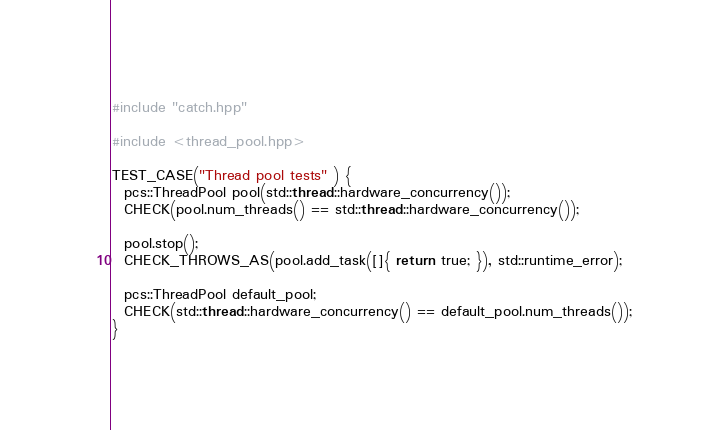<code> <loc_0><loc_0><loc_500><loc_500><_C++_>#include "catch.hpp"

#include <thread_pool.hpp>

TEST_CASE("Thread pool tests" ) {
  pcs::ThreadPool pool(std::thread::hardware_concurrency());
  CHECK(pool.num_threads() == std::thread::hardware_concurrency());
  
  pool.stop();
  CHECK_THROWS_AS(pool.add_task([]{ return true; }), std::runtime_error);

  pcs::ThreadPool default_pool;
  CHECK(std::thread::hardware_concurrency() == default_pool.num_threads());
}</code> 